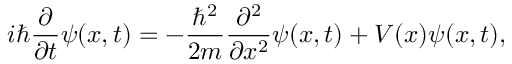Convert formula to latex. <formula><loc_0><loc_0><loc_500><loc_500>i \hbar { \frac { \partial } { \partial t } } \psi ( x , t ) = - { \frac { \hbar { ^ } { 2 } } { 2 m } } { \frac { \partial ^ { 2 } } { \partial x ^ { 2 } } } \psi ( x , t ) + V ( x ) \psi ( x , t ) ,</formula> 